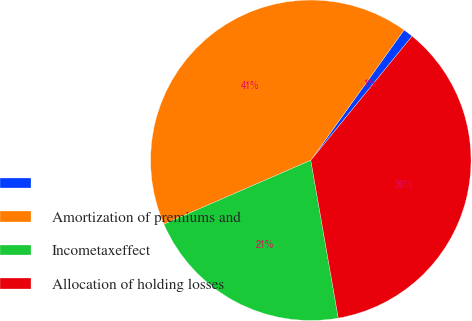Convert chart. <chart><loc_0><loc_0><loc_500><loc_500><pie_chart><ecel><fcel>Amortization of premiums and<fcel>Incometaxeffect<fcel>Allocation of holding losses<nl><fcel>1.01%<fcel>41.41%<fcel>21.21%<fcel>36.36%<nl></chart> 